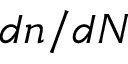<formula> <loc_0><loc_0><loc_500><loc_500>d n / d N</formula> 